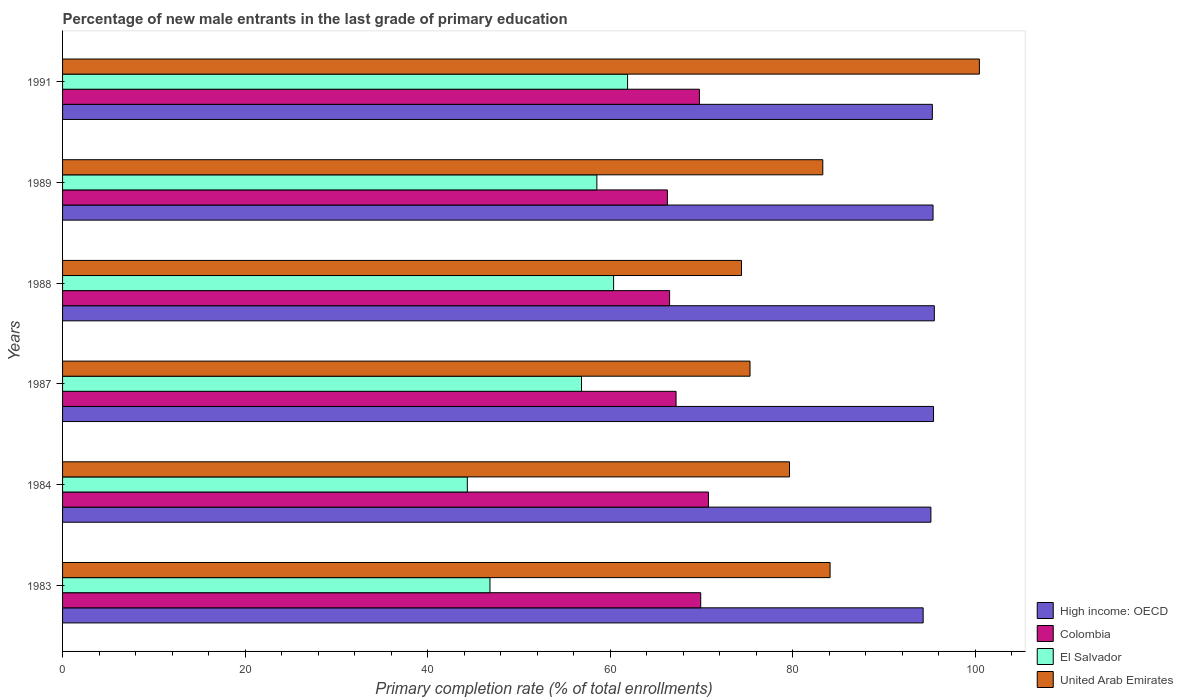How many different coloured bars are there?
Make the answer very short. 4. How many bars are there on the 5th tick from the top?
Provide a short and direct response. 4. How many bars are there on the 5th tick from the bottom?
Your answer should be very brief. 4. What is the label of the 2nd group of bars from the top?
Offer a very short reply. 1989. In how many cases, is the number of bars for a given year not equal to the number of legend labels?
Provide a short and direct response. 0. What is the percentage of new male entrants in Colombia in 1987?
Offer a terse response. 67.21. Across all years, what is the maximum percentage of new male entrants in Colombia?
Give a very brief answer. 70.76. Across all years, what is the minimum percentage of new male entrants in United Arab Emirates?
Give a very brief answer. 74.38. In which year was the percentage of new male entrants in El Salvador maximum?
Keep it short and to the point. 1991. In which year was the percentage of new male entrants in High income: OECD minimum?
Your answer should be compact. 1983. What is the total percentage of new male entrants in Colombia in the graph?
Give a very brief answer. 410.39. What is the difference between the percentage of new male entrants in El Salvador in 1984 and that in 1991?
Offer a terse response. -17.56. What is the difference between the percentage of new male entrants in Colombia in 1988 and the percentage of new male entrants in High income: OECD in 1984?
Provide a short and direct response. -28.62. What is the average percentage of new male entrants in Colombia per year?
Offer a very short reply. 68.4. In the year 1991, what is the difference between the percentage of new male entrants in Colombia and percentage of new male entrants in El Salvador?
Your response must be concise. 7.87. What is the ratio of the percentage of new male entrants in Colombia in 1983 to that in 1988?
Make the answer very short. 1.05. Is the percentage of new male entrants in United Arab Emirates in 1989 less than that in 1991?
Your response must be concise. Yes. Is the difference between the percentage of new male entrants in Colombia in 1984 and 1991 greater than the difference between the percentage of new male entrants in El Salvador in 1984 and 1991?
Give a very brief answer. Yes. What is the difference between the highest and the second highest percentage of new male entrants in El Salvador?
Keep it short and to the point. 1.53. What is the difference between the highest and the lowest percentage of new male entrants in Colombia?
Your answer should be very brief. 4.5. What does the 4th bar from the bottom in 1989 represents?
Offer a very short reply. United Arab Emirates. Is it the case that in every year, the sum of the percentage of new male entrants in Colombia and percentage of new male entrants in High income: OECD is greater than the percentage of new male entrants in El Salvador?
Your response must be concise. Yes. How many bars are there?
Your answer should be compact. 24. Are all the bars in the graph horizontal?
Provide a short and direct response. Yes. How many years are there in the graph?
Make the answer very short. 6. Are the values on the major ticks of X-axis written in scientific E-notation?
Provide a short and direct response. No. How are the legend labels stacked?
Make the answer very short. Vertical. What is the title of the graph?
Provide a short and direct response. Percentage of new male entrants in the last grade of primary education. Does "Cabo Verde" appear as one of the legend labels in the graph?
Your answer should be very brief. No. What is the label or title of the X-axis?
Provide a short and direct response. Primary completion rate (% of total enrollments). What is the label or title of the Y-axis?
Give a very brief answer. Years. What is the Primary completion rate (% of total enrollments) of High income: OECD in 1983?
Your answer should be very brief. 94.27. What is the Primary completion rate (% of total enrollments) of Colombia in 1983?
Make the answer very short. 69.91. What is the Primary completion rate (% of total enrollments) in El Salvador in 1983?
Your answer should be very brief. 46.82. What is the Primary completion rate (% of total enrollments) in United Arab Emirates in 1983?
Provide a short and direct response. 84.08. What is the Primary completion rate (% of total enrollments) in High income: OECD in 1984?
Your answer should be compact. 95.12. What is the Primary completion rate (% of total enrollments) of Colombia in 1984?
Make the answer very short. 70.76. What is the Primary completion rate (% of total enrollments) of El Salvador in 1984?
Make the answer very short. 44.34. What is the Primary completion rate (% of total enrollments) in United Arab Emirates in 1984?
Your answer should be very brief. 79.63. What is the Primary completion rate (% of total enrollments) of High income: OECD in 1987?
Ensure brevity in your answer.  95.41. What is the Primary completion rate (% of total enrollments) in Colombia in 1987?
Keep it short and to the point. 67.21. What is the Primary completion rate (% of total enrollments) of El Salvador in 1987?
Your answer should be very brief. 56.85. What is the Primary completion rate (% of total enrollments) in United Arab Emirates in 1987?
Make the answer very short. 75.31. What is the Primary completion rate (% of total enrollments) in High income: OECD in 1988?
Your response must be concise. 95.5. What is the Primary completion rate (% of total enrollments) in Colombia in 1988?
Keep it short and to the point. 66.5. What is the Primary completion rate (% of total enrollments) of El Salvador in 1988?
Your response must be concise. 60.36. What is the Primary completion rate (% of total enrollments) of United Arab Emirates in 1988?
Make the answer very short. 74.38. What is the Primary completion rate (% of total enrollments) in High income: OECD in 1989?
Make the answer very short. 95.36. What is the Primary completion rate (% of total enrollments) in Colombia in 1989?
Your answer should be compact. 66.26. What is the Primary completion rate (% of total enrollments) of El Salvador in 1989?
Offer a terse response. 58.53. What is the Primary completion rate (% of total enrollments) of United Arab Emirates in 1989?
Keep it short and to the point. 83.28. What is the Primary completion rate (% of total enrollments) of High income: OECD in 1991?
Your response must be concise. 95.28. What is the Primary completion rate (% of total enrollments) of Colombia in 1991?
Give a very brief answer. 69.77. What is the Primary completion rate (% of total enrollments) in El Salvador in 1991?
Provide a short and direct response. 61.9. What is the Primary completion rate (% of total enrollments) of United Arab Emirates in 1991?
Provide a succinct answer. 100.43. Across all years, what is the maximum Primary completion rate (% of total enrollments) of High income: OECD?
Make the answer very short. 95.5. Across all years, what is the maximum Primary completion rate (% of total enrollments) of Colombia?
Ensure brevity in your answer.  70.76. Across all years, what is the maximum Primary completion rate (% of total enrollments) of El Salvador?
Offer a very short reply. 61.9. Across all years, what is the maximum Primary completion rate (% of total enrollments) in United Arab Emirates?
Make the answer very short. 100.43. Across all years, what is the minimum Primary completion rate (% of total enrollments) of High income: OECD?
Your response must be concise. 94.27. Across all years, what is the minimum Primary completion rate (% of total enrollments) of Colombia?
Give a very brief answer. 66.26. Across all years, what is the minimum Primary completion rate (% of total enrollments) in El Salvador?
Give a very brief answer. 44.34. Across all years, what is the minimum Primary completion rate (% of total enrollments) in United Arab Emirates?
Keep it short and to the point. 74.38. What is the total Primary completion rate (% of total enrollments) of High income: OECD in the graph?
Your answer should be very brief. 570.95. What is the total Primary completion rate (% of total enrollments) of Colombia in the graph?
Your response must be concise. 410.39. What is the total Primary completion rate (% of total enrollments) of El Salvador in the graph?
Ensure brevity in your answer.  328.8. What is the total Primary completion rate (% of total enrollments) in United Arab Emirates in the graph?
Your response must be concise. 497.11. What is the difference between the Primary completion rate (% of total enrollments) of High income: OECD in 1983 and that in 1984?
Keep it short and to the point. -0.85. What is the difference between the Primary completion rate (% of total enrollments) in Colombia in 1983 and that in 1984?
Offer a terse response. -0.85. What is the difference between the Primary completion rate (% of total enrollments) in El Salvador in 1983 and that in 1984?
Offer a very short reply. 2.48. What is the difference between the Primary completion rate (% of total enrollments) in United Arab Emirates in 1983 and that in 1984?
Provide a short and direct response. 4.44. What is the difference between the Primary completion rate (% of total enrollments) in High income: OECD in 1983 and that in 1987?
Make the answer very short. -1.14. What is the difference between the Primary completion rate (% of total enrollments) in Colombia in 1983 and that in 1987?
Keep it short and to the point. 2.7. What is the difference between the Primary completion rate (% of total enrollments) of El Salvador in 1983 and that in 1987?
Make the answer very short. -10.03. What is the difference between the Primary completion rate (% of total enrollments) of United Arab Emirates in 1983 and that in 1987?
Your answer should be compact. 8.77. What is the difference between the Primary completion rate (% of total enrollments) in High income: OECD in 1983 and that in 1988?
Make the answer very short. -1.22. What is the difference between the Primary completion rate (% of total enrollments) in Colombia in 1983 and that in 1988?
Make the answer very short. 3.41. What is the difference between the Primary completion rate (% of total enrollments) in El Salvador in 1983 and that in 1988?
Offer a very short reply. -13.54. What is the difference between the Primary completion rate (% of total enrollments) of United Arab Emirates in 1983 and that in 1988?
Ensure brevity in your answer.  9.7. What is the difference between the Primary completion rate (% of total enrollments) of High income: OECD in 1983 and that in 1989?
Provide a short and direct response. -1.08. What is the difference between the Primary completion rate (% of total enrollments) of Colombia in 1983 and that in 1989?
Your answer should be compact. 3.65. What is the difference between the Primary completion rate (% of total enrollments) in El Salvador in 1983 and that in 1989?
Your answer should be very brief. -11.71. What is the difference between the Primary completion rate (% of total enrollments) in United Arab Emirates in 1983 and that in 1989?
Keep it short and to the point. 0.8. What is the difference between the Primary completion rate (% of total enrollments) of High income: OECD in 1983 and that in 1991?
Give a very brief answer. -1.01. What is the difference between the Primary completion rate (% of total enrollments) in Colombia in 1983 and that in 1991?
Make the answer very short. 0.14. What is the difference between the Primary completion rate (% of total enrollments) in El Salvador in 1983 and that in 1991?
Ensure brevity in your answer.  -15.07. What is the difference between the Primary completion rate (% of total enrollments) of United Arab Emirates in 1983 and that in 1991?
Provide a short and direct response. -16.36. What is the difference between the Primary completion rate (% of total enrollments) in High income: OECD in 1984 and that in 1987?
Offer a very short reply. -0.29. What is the difference between the Primary completion rate (% of total enrollments) of Colombia in 1984 and that in 1987?
Offer a very short reply. 3.55. What is the difference between the Primary completion rate (% of total enrollments) in El Salvador in 1984 and that in 1987?
Ensure brevity in your answer.  -12.51. What is the difference between the Primary completion rate (% of total enrollments) in United Arab Emirates in 1984 and that in 1987?
Provide a short and direct response. 4.33. What is the difference between the Primary completion rate (% of total enrollments) in High income: OECD in 1984 and that in 1988?
Your response must be concise. -0.38. What is the difference between the Primary completion rate (% of total enrollments) of Colombia in 1984 and that in 1988?
Offer a terse response. 4.26. What is the difference between the Primary completion rate (% of total enrollments) of El Salvador in 1984 and that in 1988?
Provide a short and direct response. -16.02. What is the difference between the Primary completion rate (% of total enrollments) of United Arab Emirates in 1984 and that in 1988?
Offer a terse response. 5.26. What is the difference between the Primary completion rate (% of total enrollments) of High income: OECD in 1984 and that in 1989?
Offer a very short reply. -0.24. What is the difference between the Primary completion rate (% of total enrollments) of Colombia in 1984 and that in 1989?
Ensure brevity in your answer.  4.5. What is the difference between the Primary completion rate (% of total enrollments) of El Salvador in 1984 and that in 1989?
Ensure brevity in your answer.  -14.19. What is the difference between the Primary completion rate (% of total enrollments) of United Arab Emirates in 1984 and that in 1989?
Your answer should be very brief. -3.65. What is the difference between the Primary completion rate (% of total enrollments) of High income: OECD in 1984 and that in 1991?
Make the answer very short. -0.16. What is the difference between the Primary completion rate (% of total enrollments) in Colombia in 1984 and that in 1991?
Provide a succinct answer. 0.99. What is the difference between the Primary completion rate (% of total enrollments) in El Salvador in 1984 and that in 1991?
Give a very brief answer. -17.56. What is the difference between the Primary completion rate (% of total enrollments) in United Arab Emirates in 1984 and that in 1991?
Ensure brevity in your answer.  -20.8. What is the difference between the Primary completion rate (% of total enrollments) in High income: OECD in 1987 and that in 1988?
Your answer should be compact. -0.09. What is the difference between the Primary completion rate (% of total enrollments) of Colombia in 1987 and that in 1988?
Provide a short and direct response. 0.71. What is the difference between the Primary completion rate (% of total enrollments) of El Salvador in 1987 and that in 1988?
Your response must be concise. -3.52. What is the difference between the Primary completion rate (% of total enrollments) in United Arab Emirates in 1987 and that in 1988?
Ensure brevity in your answer.  0.93. What is the difference between the Primary completion rate (% of total enrollments) in High income: OECD in 1987 and that in 1989?
Your response must be concise. 0.05. What is the difference between the Primary completion rate (% of total enrollments) of Colombia in 1987 and that in 1989?
Your response must be concise. 0.95. What is the difference between the Primary completion rate (% of total enrollments) in El Salvador in 1987 and that in 1989?
Your response must be concise. -1.68. What is the difference between the Primary completion rate (% of total enrollments) of United Arab Emirates in 1987 and that in 1989?
Offer a very short reply. -7.97. What is the difference between the Primary completion rate (% of total enrollments) of High income: OECD in 1987 and that in 1991?
Offer a very short reply. 0.13. What is the difference between the Primary completion rate (% of total enrollments) in Colombia in 1987 and that in 1991?
Ensure brevity in your answer.  -2.56. What is the difference between the Primary completion rate (% of total enrollments) of El Salvador in 1987 and that in 1991?
Give a very brief answer. -5.05. What is the difference between the Primary completion rate (% of total enrollments) of United Arab Emirates in 1987 and that in 1991?
Offer a very short reply. -25.13. What is the difference between the Primary completion rate (% of total enrollments) in High income: OECD in 1988 and that in 1989?
Give a very brief answer. 0.14. What is the difference between the Primary completion rate (% of total enrollments) of Colombia in 1988 and that in 1989?
Provide a succinct answer. 0.24. What is the difference between the Primary completion rate (% of total enrollments) in El Salvador in 1988 and that in 1989?
Keep it short and to the point. 1.84. What is the difference between the Primary completion rate (% of total enrollments) of United Arab Emirates in 1988 and that in 1989?
Make the answer very short. -8.9. What is the difference between the Primary completion rate (% of total enrollments) in High income: OECD in 1988 and that in 1991?
Ensure brevity in your answer.  0.22. What is the difference between the Primary completion rate (% of total enrollments) of Colombia in 1988 and that in 1991?
Make the answer very short. -3.27. What is the difference between the Primary completion rate (% of total enrollments) of El Salvador in 1988 and that in 1991?
Offer a very short reply. -1.53. What is the difference between the Primary completion rate (% of total enrollments) of United Arab Emirates in 1988 and that in 1991?
Offer a terse response. -26.06. What is the difference between the Primary completion rate (% of total enrollments) of High income: OECD in 1989 and that in 1991?
Offer a very short reply. 0.07. What is the difference between the Primary completion rate (% of total enrollments) of Colombia in 1989 and that in 1991?
Keep it short and to the point. -3.51. What is the difference between the Primary completion rate (% of total enrollments) in El Salvador in 1989 and that in 1991?
Provide a short and direct response. -3.37. What is the difference between the Primary completion rate (% of total enrollments) of United Arab Emirates in 1989 and that in 1991?
Make the answer very short. -17.15. What is the difference between the Primary completion rate (% of total enrollments) in High income: OECD in 1983 and the Primary completion rate (% of total enrollments) in Colombia in 1984?
Ensure brevity in your answer.  23.52. What is the difference between the Primary completion rate (% of total enrollments) of High income: OECD in 1983 and the Primary completion rate (% of total enrollments) of El Salvador in 1984?
Offer a terse response. 49.93. What is the difference between the Primary completion rate (% of total enrollments) in High income: OECD in 1983 and the Primary completion rate (% of total enrollments) in United Arab Emirates in 1984?
Keep it short and to the point. 14.64. What is the difference between the Primary completion rate (% of total enrollments) of Colombia in 1983 and the Primary completion rate (% of total enrollments) of El Salvador in 1984?
Give a very brief answer. 25.57. What is the difference between the Primary completion rate (% of total enrollments) in Colombia in 1983 and the Primary completion rate (% of total enrollments) in United Arab Emirates in 1984?
Ensure brevity in your answer.  -9.73. What is the difference between the Primary completion rate (% of total enrollments) of El Salvador in 1983 and the Primary completion rate (% of total enrollments) of United Arab Emirates in 1984?
Keep it short and to the point. -32.81. What is the difference between the Primary completion rate (% of total enrollments) in High income: OECD in 1983 and the Primary completion rate (% of total enrollments) in Colombia in 1987?
Offer a terse response. 27.07. What is the difference between the Primary completion rate (% of total enrollments) of High income: OECD in 1983 and the Primary completion rate (% of total enrollments) of El Salvador in 1987?
Give a very brief answer. 37.43. What is the difference between the Primary completion rate (% of total enrollments) of High income: OECD in 1983 and the Primary completion rate (% of total enrollments) of United Arab Emirates in 1987?
Your answer should be compact. 18.97. What is the difference between the Primary completion rate (% of total enrollments) of Colombia in 1983 and the Primary completion rate (% of total enrollments) of El Salvador in 1987?
Make the answer very short. 13.06. What is the difference between the Primary completion rate (% of total enrollments) in Colombia in 1983 and the Primary completion rate (% of total enrollments) in United Arab Emirates in 1987?
Your answer should be very brief. -5.4. What is the difference between the Primary completion rate (% of total enrollments) in El Salvador in 1983 and the Primary completion rate (% of total enrollments) in United Arab Emirates in 1987?
Keep it short and to the point. -28.49. What is the difference between the Primary completion rate (% of total enrollments) of High income: OECD in 1983 and the Primary completion rate (% of total enrollments) of Colombia in 1988?
Ensure brevity in your answer.  27.77. What is the difference between the Primary completion rate (% of total enrollments) of High income: OECD in 1983 and the Primary completion rate (% of total enrollments) of El Salvador in 1988?
Offer a terse response. 33.91. What is the difference between the Primary completion rate (% of total enrollments) of High income: OECD in 1983 and the Primary completion rate (% of total enrollments) of United Arab Emirates in 1988?
Provide a short and direct response. 19.9. What is the difference between the Primary completion rate (% of total enrollments) in Colombia in 1983 and the Primary completion rate (% of total enrollments) in El Salvador in 1988?
Make the answer very short. 9.54. What is the difference between the Primary completion rate (% of total enrollments) in Colombia in 1983 and the Primary completion rate (% of total enrollments) in United Arab Emirates in 1988?
Provide a succinct answer. -4.47. What is the difference between the Primary completion rate (% of total enrollments) in El Salvador in 1983 and the Primary completion rate (% of total enrollments) in United Arab Emirates in 1988?
Give a very brief answer. -27.56. What is the difference between the Primary completion rate (% of total enrollments) of High income: OECD in 1983 and the Primary completion rate (% of total enrollments) of Colombia in 1989?
Offer a very short reply. 28.02. What is the difference between the Primary completion rate (% of total enrollments) in High income: OECD in 1983 and the Primary completion rate (% of total enrollments) in El Salvador in 1989?
Give a very brief answer. 35.75. What is the difference between the Primary completion rate (% of total enrollments) in High income: OECD in 1983 and the Primary completion rate (% of total enrollments) in United Arab Emirates in 1989?
Ensure brevity in your answer.  10.99. What is the difference between the Primary completion rate (% of total enrollments) in Colombia in 1983 and the Primary completion rate (% of total enrollments) in El Salvador in 1989?
Your answer should be compact. 11.38. What is the difference between the Primary completion rate (% of total enrollments) in Colombia in 1983 and the Primary completion rate (% of total enrollments) in United Arab Emirates in 1989?
Your response must be concise. -13.37. What is the difference between the Primary completion rate (% of total enrollments) of El Salvador in 1983 and the Primary completion rate (% of total enrollments) of United Arab Emirates in 1989?
Make the answer very short. -36.46. What is the difference between the Primary completion rate (% of total enrollments) in High income: OECD in 1983 and the Primary completion rate (% of total enrollments) in Colombia in 1991?
Your answer should be compact. 24.51. What is the difference between the Primary completion rate (% of total enrollments) in High income: OECD in 1983 and the Primary completion rate (% of total enrollments) in El Salvador in 1991?
Provide a succinct answer. 32.38. What is the difference between the Primary completion rate (% of total enrollments) of High income: OECD in 1983 and the Primary completion rate (% of total enrollments) of United Arab Emirates in 1991?
Offer a terse response. -6.16. What is the difference between the Primary completion rate (% of total enrollments) in Colombia in 1983 and the Primary completion rate (% of total enrollments) in El Salvador in 1991?
Your answer should be very brief. 8.01. What is the difference between the Primary completion rate (% of total enrollments) of Colombia in 1983 and the Primary completion rate (% of total enrollments) of United Arab Emirates in 1991?
Offer a terse response. -30.53. What is the difference between the Primary completion rate (% of total enrollments) of El Salvador in 1983 and the Primary completion rate (% of total enrollments) of United Arab Emirates in 1991?
Provide a succinct answer. -53.61. What is the difference between the Primary completion rate (% of total enrollments) of High income: OECD in 1984 and the Primary completion rate (% of total enrollments) of Colombia in 1987?
Ensure brevity in your answer.  27.92. What is the difference between the Primary completion rate (% of total enrollments) of High income: OECD in 1984 and the Primary completion rate (% of total enrollments) of El Salvador in 1987?
Ensure brevity in your answer.  38.27. What is the difference between the Primary completion rate (% of total enrollments) in High income: OECD in 1984 and the Primary completion rate (% of total enrollments) in United Arab Emirates in 1987?
Offer a very short reply. 19.81. What is the difference between the Primary completion rate (% of total enrollments) in Colombia in 1984 and the Primary completion rate (% of total enrollments) in El Salvador in 1987?
Your answer should be very brief. 13.91. What is the difference between the Primary completion rate (% of total enrollments) in Colombia in 1984 and the Primary completion rate (% of total enrollments) in United Arab Emirates in 1987?
Offer a very short reply. -4.55. What is the difference between the Primary completion rate (% of total enrollments) of El Salvador in 1984 and the Primary completion rate (% of total enrollments) of United Arab Emirates in 1987?
Your answer should be very brief. -30.97. What is the difference between the Primary completion rate (% of total enrollments) of High income: OECD in 1984 and the Primary completion rate (% of total enrollments) of Colombia in 1988?
Ensure brevity in your answer.  28.62. What is the difference between the Primary completion rate (% of total enrollments) in High income: OECD in 1984 and the Primary completion rate (% of total enrollments) in El Salvador in 1988?
Ensure brevity in your answer.  34.76. What is the difference between the Primary completion rate (% of total enrollments) of High income: OECD in 1984 and the Primary completion rate (% of total enrollments) of United Arab Emirates in 1988?
Provide a short and direct response. 20.75. What is the difference between the Primary completion rate (% of total enrollments) of Colombia in 1984 and the Primary completion rate (% of total enrollments) of El Salvador in 1988?
Make the answer very short. 10.39. What is the difference between the Primary completion rate (% of total enrollments) in Colombia in 1984 and the Primary completion rate (% of total enrollments) in United Arab Emirates in 1988?
Your answer should be compact. -3.62. What is the difference between the Primary completion rate (% of total enrollments) in El Salvador in 1984 and the Primary completion rate (% of total enrollments) in United Arab Emirates in 1988?
Your response must be concise. -30.04. What is the difference between the Primary completion rate (% of total enrollments) of High income: OECD in 1984 and the Primary completion rate (% of total enrollments) of Colombia in 1989?
Offer a very short reply. 28.87. What is the difference between the Primary completion rate (% of total enrollments) in High income: OECD in 1984 and the Primary completion rate (% of total enrollments) in El Salvador in 1989?
Keep it short and to the point. 36.59. What is the difference between the Primary completion rate (% of total enrollments) in High income: OECD in 1984 and the Primary completion rate (% of total enrollments) in United Arab Emirates in 1989?
Provide a succinct answer. 11.84. What is the difference between the Primary completion rate (% of total enrollments) in Colombia in 1984 and the Primary completion rate (% of total enrollments) in El Salvador in 1989?
Give a very brief answer. 12.23. What is the difference between the Primary completion rate (% of total enrollments) of Colombia in 1984 and the Primary completion rate (% of total enrollments) of United Arab Emirates in 1989?
Give a very brief answer. -12.53. What is the difference between the Primary completion rate (% of total enrollments) of El Salvador in 1984 and the Primary completion rate (% of total enrollments) of United Arab Emirates in 1989?
Your answer should be compact. -38.94. What is the difference between the Primary completion rate (% of total enrollments) of High income: OECD in 1984 and the Primary completion rate (% of total enrollments) of Colombia in 1991?
Make the answer very short. 25.36. What is the difference between the Primary completion rate (% of total enrollments) in High income: OECD in 1984 and the Primary completion rate (% of total enrollments) in El Salvador in 1991?
Keep it short and to the point. 33.23. What is the difference between the Primary completion rate (% of total enrollments) of High income: OECD in 1984 and the Primary completion rate (% of total enrollments) of United Arab Emirates in 1991?
Give a very brief answer. -5.31. What is the difference between the Primary completion rate (% of total enrollments) in Colombia in 1984 and the Primary completion rate (% of total enrollments) in El Salvador in 1991?
Make the answer very short. 8.86. What is the difference between the Primary completion rate (% of total enrollments) in Colombia in 1984 and the Primary completion rate (% of total enrollments) in United Arab Emirates in 1991?
Provide a short and direct response. -29.68. What is the difference between the Primary completion rate (% of total enrollments) of El Salvador in 1984 and the Primary completion rate (% of total enrollments) of United Arab Emirates in 1991?
Provide a short and direct response. -56.09. What is the difference between the Primary completion rate (% of total enrollments) in High income: OECD in 1987 and the Primary completion rate (% of total enrollments) in Colombia in 1988?
Ensure brevity in your answer.  28.91. What is the difference between the Primary completion rate (% of total enrollments) of High income: OECD in 1987 and the Primary completion rate (% of total enrollments) of El Salvador in 1988?
Offer a terse response. 35.05. What is the difference between the Primary completion rate (% of total enrollments) of High income: OECD in 1987 and the Primary completion rate (% of total enrollments) of United Arab Emirates in 1988?
Your response must be concise. 21.04. What is the difference between the Primary completion rate (% of total enrollments) in Colombia in 1987 and the Primary completion rate (% of total enrollments) in El Salvador in 1988?
Keep it short and to the point. 6.84. What is the difference between the Primary completion rate (% of total enrollments) in Colombia in 1987 and the Primary completion rate (% of total enrollments) in United Arab Emirates in 1988?
Offer a terse response. -7.17. What is the difference between the Primary completion rate (% of total enrollments) of El Salvador in 1987 and the Primary completion rate (% of total enrollments) of United Arab Emirates in 1988?
Provide a succinct answer. -17.53. What is the difference between the Primary completion rate (% of total enrollments) in High income: OECD in 1987 and the Primary completion rate (% of total enrollments) in Colombia in 1989?
Keep it short and to the point. 29.15. What is the difference between the Primary completion rate (% of total enrollments) in High income: OECD in 1987 and the Primary completion rate (% of total enrollments) in El Salvador in 1989?
Make the answer very short. 36.88. What is the difference between the Primary completion rate (% of total enrollments) of High income: OECD in 1987 and the Primary completion rate (% of total enrollments) of United Arab Emirates in 1989?
Offer a very short reply. 12.13. What is the difference between the Primary completion rate (% of total enrollments) of Colombia in 1987 and the Primary completion rate (% of total enrollments) of El Salvador in 1989?
Keep it short and to the point. 8.68. What is the difference between the Primary completion rate (% of total enrollments) in Colombia in 1987 and the Primary completion rate (% of total enrollments) in United Arab Emirates in 1989?
Offer a very short reply. -16.07. What is the difference between the Primary completion rate (% of total enrollments) of El Salvador in 1987 and the Primary completion rate (% of total enrollments) of United Arab Emirates in 1989?
Provide a succinct answer. -26.43. What is the difference between the Primary completion rate (% of total enrollments) in High income: OECD in 1987 and the Primary completion rate (% of total enrollments) in Colombia in 1991?
Provide a succinct answer. 25.64. What is the difference between the Primary completion rate (% of total enrollments) in High income: OECD in 1987 and the Primary completion rate (% of total enrollments) in El Salvador in 1991?
Give a very brief answer. 33.52. What is the difference between the Primary completion rate (% of total enrollments) of High income: OECD in 1987 and the Primary completion rate (% of total enrollments) of United Arab Emirates in 1991?
Your response must be concise. -5.02. What is the difference between the Primary completion rate (% of total enrollments) in Colombia in 1987 and the Primary completion rate (% of total enrollments) in El Salvador in 1991?
Offer a terse response. 5.31. What is the difference between the Primary completion rate (% of total enrollments) of Colombia in 1987 and the Primary completion rate (% of total enrollments) of United Arab Emirates in 1991?
Provide a succinct answer. -33.23. What is the difference between the Primary completion rate (% of total enrollments) in El Salvador in 1987 and the Primary completion rate (% of total enrollments) in United Arab Emirates in 1991?
Offer a terse response. -43.59. What is the difference between the Primary completion rate (% of total enrollments) in High income: OECD in 1988 and the Primary completion rate (% of total enrollments) in Colombia in 1989?
Your answer should be compact. 29.24. What is the difference between the Primary completion rate (% of total enrollments) in High income: OECD in 1988 and the Primary completion rate (% of total enrollments) in El Salvador in 1989?
Make the answer very short. 36.97. What is the difference between the Primary completion rate (% of total enrollments) in High income: OECD in 1988 and the Primary completion rate (% of total enrollments) in United Arab Emirates in 1989?
Offer a terse response. 12.22. What is the difference between the Primary completion rate (% of total enrollments) of Colombia in 1988 and the Primary completion rate (% of total enrollments) of El Salvador in 1989?
Make the answer very short. 7.97. What is the difference between the Primary completion rate (% of total enrollments) of Colombia in 1988 and the Primary completion rate (% of total enrollments) of United Arab Emirates in 1989?
Ensure brevity in your answer.  -16.78. What is the difference between the Primary completion rate (% of total enrollments) of El Salvador in 1988 and the Primary completion rate (% of total enrollments) of United Arab Emirates in 1989?
Ensure brevity in your answer.  -22.92. What is the difference between the Primary completion rate (% of total enrollments) of High income: OECD in 1988 and the Primary completion rate (% of total enrollments) of Colombia in 1991?
Offer a terse response. 25.73. What is the difference between the Primary completion rate (% of total enrollments) in High income: OECD in 1988 and the Primary completion rate (% of total enrollments) in El Salvador in 1991?
Keep it short and to the point. 33.6. What is the difference between the Primary completion rate (% of total enrollments) of High income: OECD in 1988 and the Primary completion rate (% of total enrollments) of United Arab Emirates in 1991?
Give a very brief answer. -4.94. What is the difference between the Primary completion rate (% of total enrollments) in Colombia in 1988 and the Primary completion rate (% of total enrollments) in El Salvador in 1991?
Provide a short and direct response. 4.6. What is the difference between the Primary completion rate (% of total enrollments) of Colombia in 1988 and the Primary completion rate (% of total enrollments) of United Arab Emirates in 1991?
Make the answer very short. -33.93. What is the difference between the Primary completion rate (% of total enrollments) in El Salvador in 1988 and the Primary completion rate (% of total enrollments) in United Arab Emirates in 1991?
Make the answer very short. -40.07. What is the difference between the Primary completion rate (% of total enrollments) in High income: OECD in 1989 and the Primary completion rate (% of total enrollments) in Colombia in 1991?
Make the answer very short. 25.59. What is the difference between the Primary completion rate (% of total enrollments) in High income: OECD in 1989 and the Primary completion rate (% of total enrollments) in El Salvador in 1991?
Make the answer very short. 33.46. What is the difference between the Primary completion rate (% of total enrollments) of High income: OECD in 1989 and the Primary completion rate (% of total enrollments) of United Arab Emirates in 1991?
Ensure brevity in your answer.  -5.08. What is the difference between the Primary completion rate (% of total enrollments) of Colombia in 1989 and the Primary completion rate (% of total enrollments) of El Salvador in 1991?
Your response must be concise. 4.36. What is the difference between the Primary completion rate (% of total enrollments) in Colombia in 1989 and the Primary completion rate (% of total enrollments) in United Arab Emirates in 1991?
Offer a terse response. -34.18. What is the difference between the Primary completion rate (% of total enrollments) in El Salvador in 1989 and the Primary completion rate (% of total enrollments) in United Arab Emirates in 1991?
Your answer should be very brief. -41.91. What is the average Primary completion rate (% of total enrollments) of High income: OECD per year?
Provide a succinct answer. 95.16. What is the average Primary completion rate (% of total enrollments) of Colombia per year?
Ensure brevity in your answer.  68.4. What is the average Primary completion rate (% of total enrollments) in El Salvador per year?
Your response must be concise. 54.8. What is the average Primary completion rate (% of total enrollments) of United Arab Emirates per year?
Offer a terse response. 82.85. In the year 1983, what is the difference between the Primary completion rate (% of total enrollments) in High income: OECD and Primary completion rate (% of total enrollments) in Colombia?
Your answer should be compact. 24.37. In the year 1983, what is the difference between the Primary completion rate (% of total enrollments) in High income: OECD and Primary completion rate (% of total enrollments) in El Salvador?
Your answer should be compact. 47.45. In the year 1983, what is the difference between the Primary completion rate (% of total enrollments) in High income: OECD and Primary completion rate (% of total enrollments) in United Arab Emirates?
Your response must be concise. 10.2. In the year 1983, what is the difference between the Primary completion rate (% of total enrollments) in Colombia and Primary completion rate (% of total enrollments) in El Salvador?
Offer a terse response. 23.09. In the year 1983, what is the difference between the Primary completion rate (% of total enrollments) of Colombia and Primary completion rate (% of total enrollments) of United Arab Emirates?
Provide a short and direct response. -14.17. In the year 1983, what is the difference between the Primary completion rate (% of total enrollments) in El Salvador and Primary completion rate (% of total enrollments) in United Arab Emirates?
Your answer should be compact. -37.26. In the year 1984, what is the difference between the Primary completion rate (% of total enrollments) in High income: OECD and Primary completion rate (% of total enrollments) in Colombia?
Give a very brief answer. 24.37. In the year 1984, what is the difference between the Primary completion rate (% of total enrollments) of High income: OECD and Primary completion rate (% of total enrollments) of El Salvador?
Offer a very short reply. 50.78. In the year 1984, what is the difference between the Primary completion rate (% of total enrollments) of High income: OECD and Primary completion rate (% of total enrollments) of United Arab Emirates?
Provide a short and direct response. 15.49. In the year 1984, what is the difference between the Primary completion rate (% of total enrollments) in Colombia and Primary completion rate (% of total enrollments) in El Salvador?
Ensure brevity in your answer.  26.41. In the year 1984, what is the difference between the Primary completion rate (% of total enrollments) in Colombia and Primary completion rate (% of total enrollments) in United Arab Emirates?
Your response must be concise. -8.88. In the year 1984, what is the difference between the Primary completion rate (% of total enrollments) of El Salvador and Primary completion rate (% of total enrollments) of United Arab Emirates?
Offer a terse response. -35.29. In the year 1987, what is the difference between the Primary completion rate (% of total enrollments) of High income: OECD and Primary completion rate (% of total enrollments) of Colombia?
Ensure brevity in your answer.  28.21. In the year 1987, what is the difference between the Primary completion rate (% of total enrollments) in High income: OECD and Primary completion rate (% of total enrollments) in El Salvador?
Offer a very short reply. 38.56. In the year 1987, what is the difference between the Primary completion rate (% of total enrollments) in High income: OECD and Primary completion rate (% of total enrollments) in United Arab Emirates?
Offer a very short reply. 20.1. In the year 1987, what is the difference between the Primary completion rate (% of total enrollments) of Colombia and Primary completion rate (% of total enrollments) of El Salvador?
Provide a short and direct response. 10.36. In the year 1987, what is the difference between the Primary completion rate (% of total enrollments) in Colombia and Primary completion rate (% of total enrollments) in United Arab Emirates?
Provide a short and direct response. -8.1. In the year 1987, what is the difference between the Primary completion rate (% of total enrollments) of El Salvador and Primary completion rate (% of total enrollments) of United Arab Emirates?
Your answer should be compact. -18.46. In the year 1988, what is the difference between the Primary completion rate (% of total enrollments) of High income: OECD and Primary completion rate (% of total enrollments) of Colombia?
Offer a very short reply. 29. In the year 1988, what is the difference between the Primary completion rate (% of total enrollments) of High income: OECD and Primary completion rate (% of total enrollments) of El Salvador?
Offer a very short reply. 35.13. In the year 1988, what is the difference between the Primary completion rate (% of total enrollments) of High income: OECD and Primary completion rate (% of total enrollments) of United Arab Emirates?
Give a very brief answer. 21.12. In the year 1988, what is the difference between the Primary completion rate (% of total enrollments) of Colombia and Primary completion rate (% of total enrollments) of El Salvador?
Offer a terse response. 6.13. In the year 1988, what is the difference between the Primary completion rate (% of total enrollments) in Colombia and Primary completion rate (% of total enrollments) in United Arab Emirates?
Provide a succinct answer. -7.88. In the year 1988, what is the difference between the Primary completion rate (% of total enrollments) of El Salvador and Primary completion rate (% of total enrollments) of United Arab Emirates?
Ensure brevity in your answer.  -14.01. In the year 1989, what is the difference between the Primary completion rate (% of total enrollments) in High income: OECD and Primary completion rate (% of total enrollments) in Colombia?
Your answer should be compact. 29.1. In the year 1989, what is the difference between the Primary completion rate (% of total enrollments) in High income: OECD and Primary completion rate (% of total enrollments) in El Salvador?
Your answer should be very brief. 36.83. In the year 1989, what is the difference between the Primary completion rate (% of total enrollments) of High income: OECD and Primary completion rate (% of total enrollments) of United Arab Emirates?
Offer a very short reply. 12.08. In the year 1989, what is the difference between the Primary completion rate (% of total enrollments) of Colombia and Primary completion rate (% of total enrollments) of El Salvador?
Provide a short and direct response. 7.73. In the year 1989, what is the difference between the Primary completion rate (% of total enrollments) in Colombia and Primary completion rate (% of total enrollments) in United Arab Emirates?
Ensure brevity in your answer.  -17.02. In the year 1989, what is the difference between the Primary completion rate (% of total enrollments) of El Salvador and Primary completion rate (% of total enrollments) of United Arab Emirates?
Your answer should be very brief. -24.75. In the year 1991, what is the difference between the Primary completion rate (% of total enrollments) of High income: OECD and Primary completion rate (% of total enrollments) of Colombia?
Offer a very short reply. 25.52. In the year 1991, what is the difference between the Primary completion rate (% of total enrollments) of High income: OECD and Primary completion rate (% of total enrollments) of El Salvador?
Give a very brief answer. 33.39. In the year 1991, what is the difference between the Primary completion rate (% of total enrollments) in High income: OECD and Primary completion rate (% of total enrollments) in United Arab Emirates?
Ensure brevity in your answer.  -5.15. In the year 1991, what is the difference between the Primary completion rate (% of total enrollments) in Colombia and Primary completion rate (% of total enrollments) in El Salvador?
Offer a terse response. 7.87. In the year 1991, what is the difference between the Primary completion rate (% of total enrollments) of Colombia and Primary completion rate (% of total enrollments) of United Arab Emirates?
Make the answer very short. -30.67. In the year 1991, what is the difference between the Primary completion rate (% of total enrollments) in El Salvador and Primary completion rate (% of total enrollments) in United Arab Emirates?
Your response must be concise. -38.54. What is the ratio of the Primary completion rate (% of total enrollments) in El Salvador in 1983 to that in 1984?
Provide a succinct answer. 1.06. What is the ratio of the Primary completion rate (% of total enrollments) in United Arab Emirates in 1983 to that in 1984?
Your answer should be very brief. 1.06. What is the ratio of the Primary completion rate (% of total enrollments) in High income: OECD in 1983 to that in 1987?
Give a very brief answer. 0.99. What is the ratio of the Primary completion rate (% of total enrollments) in Colombia in 1983 to that in 1987?
Your answer should be very brief. 1.04. What is the ratio of the Primary completion rate (% of total enrollments) in El Salvador in 1983 to that in 1987?
Provide a short and direct response. 0.82. What is the ratio of the Primary completion rate (% of total enrollments) in United Arab Emirates in 1983 to that in 1987?
Your answer should be compact. 1.12. What is the ratio of the Primary completion rate (% of total enrollments) of High income: OECD in 1983 to that in 1988?
Offer a terse response. 0.99. What is the ratio of the Primary completion rate (% of total enrollments) of Colombia in 1983 to that in 1988?
Your answer should be compact. 1.05. What is the ratio of the Primary completion rate (% of total enrollments) of El Salvador in 1983 to that in 1988?
Keep it short and to the point. 0.78. What is the ratio of the Primary completion rate (% of total enrollments) of United Arab Emirates in 1983 to that in 1988?
Your response must be concise. 1.13. What is the ratio of the Primary completion rate (% of total enrollments) in Colombia in 1983 to that in 1989?
Offer a terse response. 1.06. What is the ratio of the Primary completion rate (% of total enrollments) of United Arab Emirates in 1983 to that in 1989?
Offer a very short reply. 1.01. What is the ratio of the Primary completion rate (% of total enrollments) in High income: OECD in 1983 to that in 1991?
Offer a very short reply. 0.99. What is the ratio of the Primary completion rate (% of total enrollments) in El Salvador in 1983 to that in 1991?
Provide a short and direct response. 0.76. What is the ratio of the Primary completion rate (% of total enrollments) in United Arab Emirates in 1983 to that in 1991?
Your response must be concise. 0.84. What is the ratio of the Primary completion rate (% of total enrollments) in High income: OECD in 1984 to that in 1987?
Keep it short and to the point. 1. What is the ratio of the Primary completion rate (% of total enrollments) in Colombia in 1984 to that in 1987?
Provide a short and direct response. 1.05. What is the ratio of the Primary completion rate (% of total enrollments) in El Salvador in 1984 to that in 1987?
Offer a terse response. 0.78. What is the ratio of the Primary completion rate (% of total enrollments) of United Arab Emirates in 1984 to that in 1987?
Keep it short and to the point. 1.06. What is the ratio of the Primary completion rate (% of total enrollments) in High income: OECD in 1984 to that in 1988?
Your answer should be compact. 1. What is the ratio of the Primary completion rate (% of total enrollments) of Colombia in 1984 to that in 1988?
Provide a short and direct response. 1.06. What is the ratio of the Primary completion rate (% of total enrollments) of El Salvador in 1984 to that in 1988?
Your answer should be compact. 0.73. What is the ratio of the Primary completion rate (% of total enrollments) of United Arab Emirates in 1984 to that in 1988?
Offer a terse response. 1.07. What is the ratio of the Primary completion rate (% of total enrollments) of Colombia in 1984 to that in 1989?
Offer a terse response. 1.07. What is the ratio of the Primary completion rate (% of total enrollments) in El Salvador in 1984 to that in 1989?
Give a very brief answer. 0.76. What is the ratio of the Primary completion rate (% of total enrollments) in United Arab Emirates in 1984 to that in 1989?
Your answer should be very brief. 0.96. What is the ratio of the Primary completion rate (% of total enrollments) in High income: OECD in 1984 to that in 1991?
Provide a succinct answer. 1. What is the ratio of the Primary completion rate (% of total enrollments) in Colombia in 1984 to that in 1991?
Keep it short and to the point. 1.01. What is the ratio of the Primary completion rate (% of total enrollments) in El Salvador in 1984 to that in 1991?
Your answer should be very brief. 0.72. What is the ratio of the Primary completion rate (% of total enrollments) of United Arab Emirates in 1984 to that in 1991?
Your response must be concise. 0.79. What is the ratio of the Primary completion rate (% of total enrollments) in High income: OECD in 1987 to that in 1988?
Your answer should be compact. 1. What is the ratio of the Primary completion rate (% of total enrollments) of Colombia in 1987 to that in 1988?
Offer a very short reply. 1.01. What is the ratio of the Primary completion rate (% of total enrollments) in El Salvador in 1987 to that in 1988?
Your answer should be compact. 0.94. What is the ratio of the Primary completion rate (% of total enrollments) of United Arab Emirates in 1987 to that in 1988?
Your answer should be very brief. 1.01. What is the ratio of the Primary completion rate (% of total enrollments) in Colombia in 1987 to that in 1989?
Make the answer very short. 1.01. What is the ratio of the Primary completion rate (% of total enrollments) of El Salvador in 1987 to that in 1989?
Your answer should be compact. 0.97. What is the ratio of the Primary completion rate (% of total enrollments) in United Arab Emirates in 1987 to that in 1989?
Offer a terse response. 0.9. What is the ratio of the Primary completion rate (% of total enrollments) in High income: OECD in 1987 to that in 1991?
Your answer should be very brief. 1. What is the ratio of the Primary completion rate (% of total enrollments) of Colombia in 1987 to that in 1991?
Your answer should be compact. 0.96. What is the ratio of the Primary completion rate (% of total enrollments) in El Salvador in 1987 to that in 1991?
Keep it short and to the point. 0.92. What is the ratio of the Primary completion rate (% of total enrollments) of United Arab Emirates in 1987 to that in 1991?
Provide a succinct answer. 0.75. What is the ratio of the Primary completion rate (% of total enrollments) of Colombia in 1988 to that in 1989?
Your answer should be very brief. 1. What is the ratio of the Primary completion rate (% of total enrollments) in El Salvador in 1988 to that in 1989?
Ensure brevity in your answer.  1.03. What is the ratio of the Primary completion rate (% of total enrollments) of United Arab Emirates in 1988 to that in 1989?
Provide a succinct answer. 0.89. What is the ratio of the Primary completion rate (% of total enrollments) in High income: OECD in 1988 to that in 1991?
Offer a terse response. 1. What is the ratio of the Primary completion rate (% of total enrollments) in Colombia in 1988 to that in 1991?
Your response must be concise. 0.95. What is the ratio of the Primary completion rate (% of total enrollments) of El Salvador in 1988 to that in 1991?
Your answer should be compact. 0.98. What is the ratio of the Primary completion rate (% of total enrollments) in United Arab Emirates in 1988 to that in 1991?
Provide a succinct answer. 0.74. What is the ratio of the Primary completion rate (% of total enrollments) of Colombia in 1989 to that in 1991?
Your answer should be compact. 0.95. What is the ratio of the Primary completion rate (% of total enrollments) of El Salvador in 1989 to that in 1991?
Give a very brief answer. 0.95. What is the ratio of the Primary completion rate (% of total enrollments) of United Arab Emirates in 1989 to that in 1991?
Offer a terse response. 0.83. What is the difference between the highest and the second highest Primary completion rate (% of total enrollments) of High income: OECD?
Your answer should be compact. 0.09. What is the difference between the highest and the second highest Primary completion rate (% of total enrollments) in Colombia?
Provide a succinct answer. 0.85. What is the difference between the highest and the second highest Primary completion rate (% of total enrollments) of El Salvador?
Your answer should be compact. 1.53. What is the difference between the highest and the second highest Primary completion rate (% of total enrollments) of United Arab Emirates?
Provide a short and direct response. 16.36. What is the difference between the highest and the lowest Primary completion rate (% of total enrollments) of High income: OECD?
Give a very brief answer. 1.22. What is the difference between the highest and the lowest Primary completion rate (% of total enrollments) in Colombia?
Offer a terse response. 4.5. What is the difference between the highest and the lowest Primary completion rate (% of total enrollments) of El Salvador?
Your response must be concise. 17.56. What is the difference between the highest and the lowest Primary completion rate (% of total enrollments) of United Arab Emirates?
Your answer should be very brief. 26.06. 